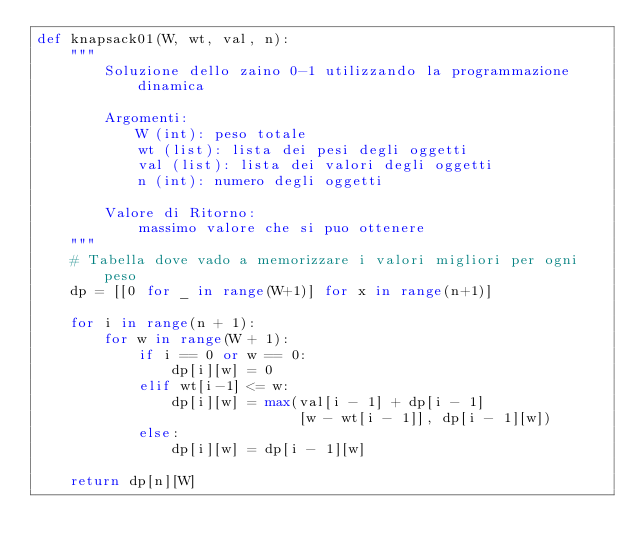<code> <loc_0><loc_0><loc_500><loc_500><_Python_>def knapsack01(W, wt, val, n):
    """
        Soluzione dello zaino 0-1 utilizzando la programmazione dinamica

        Argomenti:
            W (int): peso totale
            wt (list): lista dei pesi degli oggetti
            val (list): lista dei valori degli oggetti
            n (int): numero degli oggetti

        Valore di Ritorno:
            massimo valore che si puo ottenere
    """
    # Tabella dove vado a memorizzare i valori migliori per ogni peso
    dp = [[0 for _ in range(W+1)] for x in range(n+1)]

    for i in range(n + 1):
        for w in range(W + 1):
            if i == 0 or w == 0:
                dp[i][w] = 0
            elif wt[i-1] <= w:
                dp[i][w] = max(val[i - 1] + dp[i - 1]
                               [w - wt[i - 1]], dp[i - 1][w])
            else:
                dp[i][w] = dp[i - 1][w]

    return dp[n][W]
</code> 